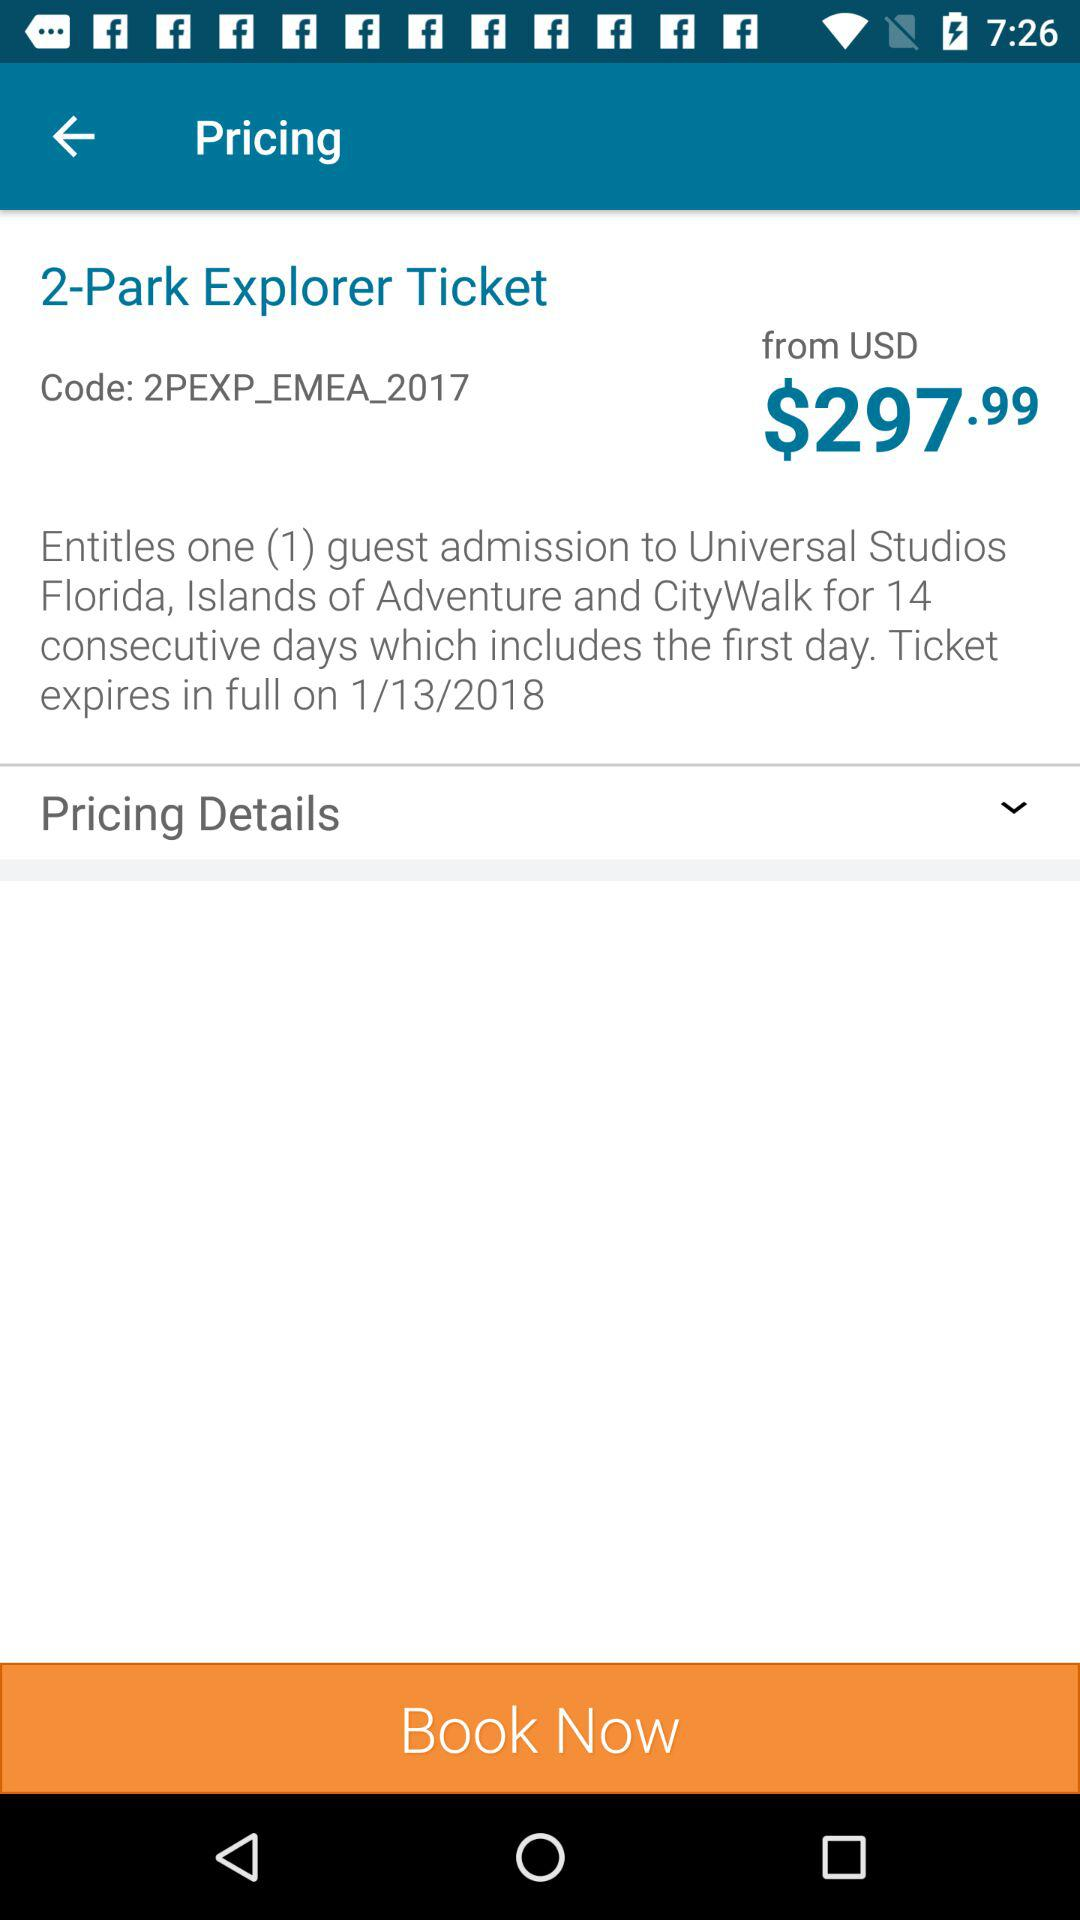What is the expiration date of the "2-Park Explorer Ticket"? The expiration date of the "2-Park Explorer Ticket" is January 13, 2018. 